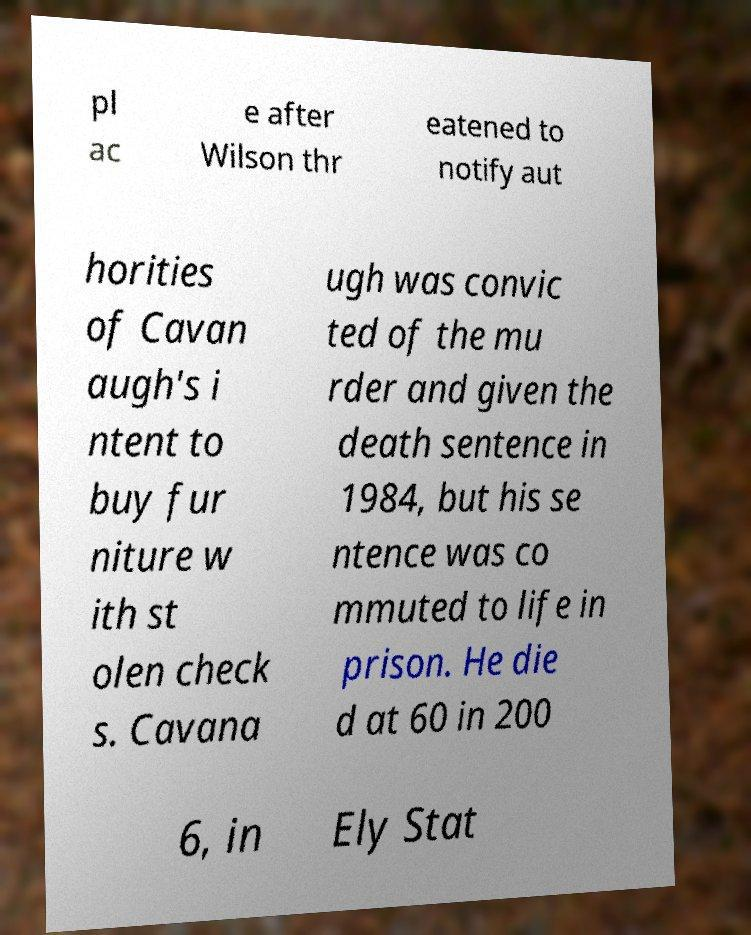Could you assist in decoding the text presented in this image and type it out clearly? pl ac e after Wilson thr eatened to notify aut horities of Cavan augh's i ntent to buy fur niture w ith st olen check s. Cavana ugh was convic ted of the mu rder and given the death sentence in 1984, but his se ntence was co mmuted to life in prison. He die d at 60 in 200 6, in Ely Stat 